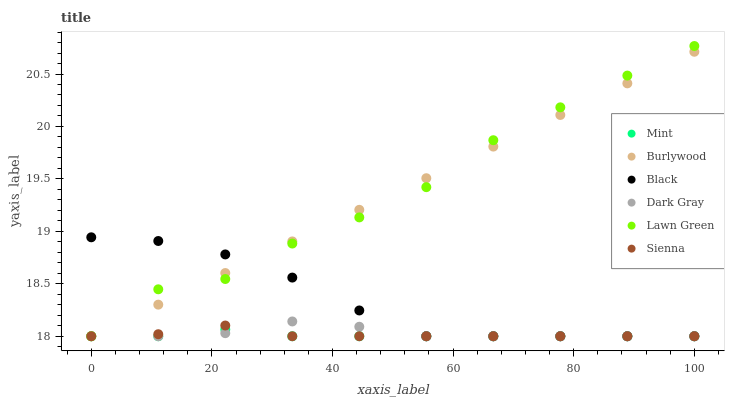Does Mint have the minimum area under the curve?
Answer yes or no. Yes. Does Lawn Green have the maximum area under the curve?
Answer yes or no. Yes. Does Burlywood have the minimum area under the curve?
Answer yes or no. No. Does Burlywood have the maximum area under the curve?
Answer yes or no. No. Is Burlywood the smoothest?
Answer yes or no. Yes. Is Lawn Green the roughest?
Answer yes or no. Yes. Is Lawn Green the smoothest?
Answer yes or no. No. Is Burlywood the roughest?
Answer yes or no. No. Does Dark Gray have the lowest value?
Answer yes or no. Yes. Does Lawn Green have the highest value?
Answer yes or no. Yes. Does Burlywood have the highest value?
Answer yes or no. No. Does Black intersect Mint?
Answer yes or no. Yes. Is Black less than Mint?
Answer yes or no. No. Is Black greater than Mint?
Answer yes or no. No. 